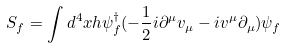Convert formula to latex. <formula><loc_0><loc_0><loc_500><loc_500>S _ { f } = \int d ^ { 4 } x h \psi _ { f } ^ { \dagger } ( - \frac { 1 } { 2 } i \partial ^ { \mu } v _ { \mu } - i v ^ { \mu } \partial _ { \mu } ) \psi _ { f }</formula> 